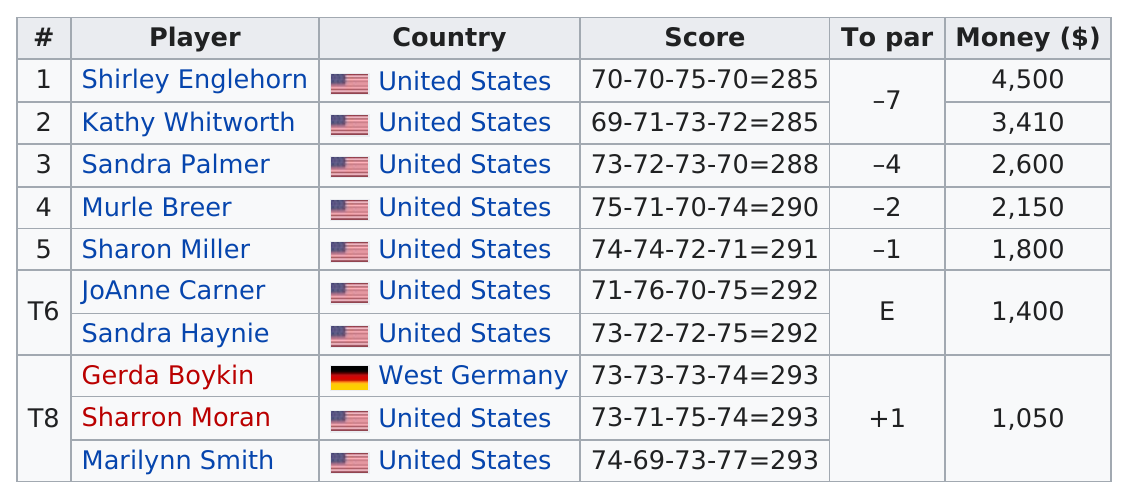Identify some key points in this picture. The golfer who was first to have 290 points on the list was Murle Breer. JoAnne Carner received the same score as Sandra Haynie, a competitor. The two individuals named JoAnne Carner and Sandra Haynie were tied at par, meaning they both achieved equal scores during a certain competition or event. There were three competitors who tied for last place in the final leaderboard. The difference between the number 5 and T8 is 750. 